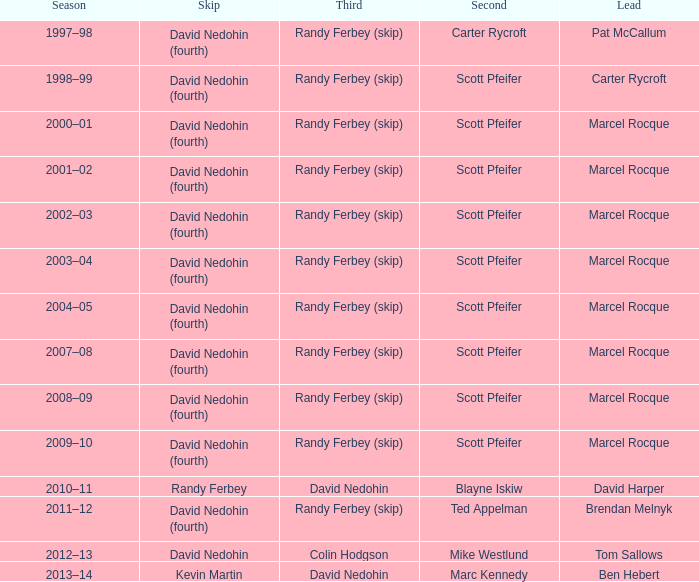In which third can a second of scott pfeifer be found? Randy Ferbey (skip), Randy Ferbey (skip), Randy Ferbey (skip), Randy Ferbey (skip), Randy Ferbey (skip), Randy Ferbey (skip), Randy Ferbey (skip), Randy Ferbey (skip), Randy Ferbey (skip). 